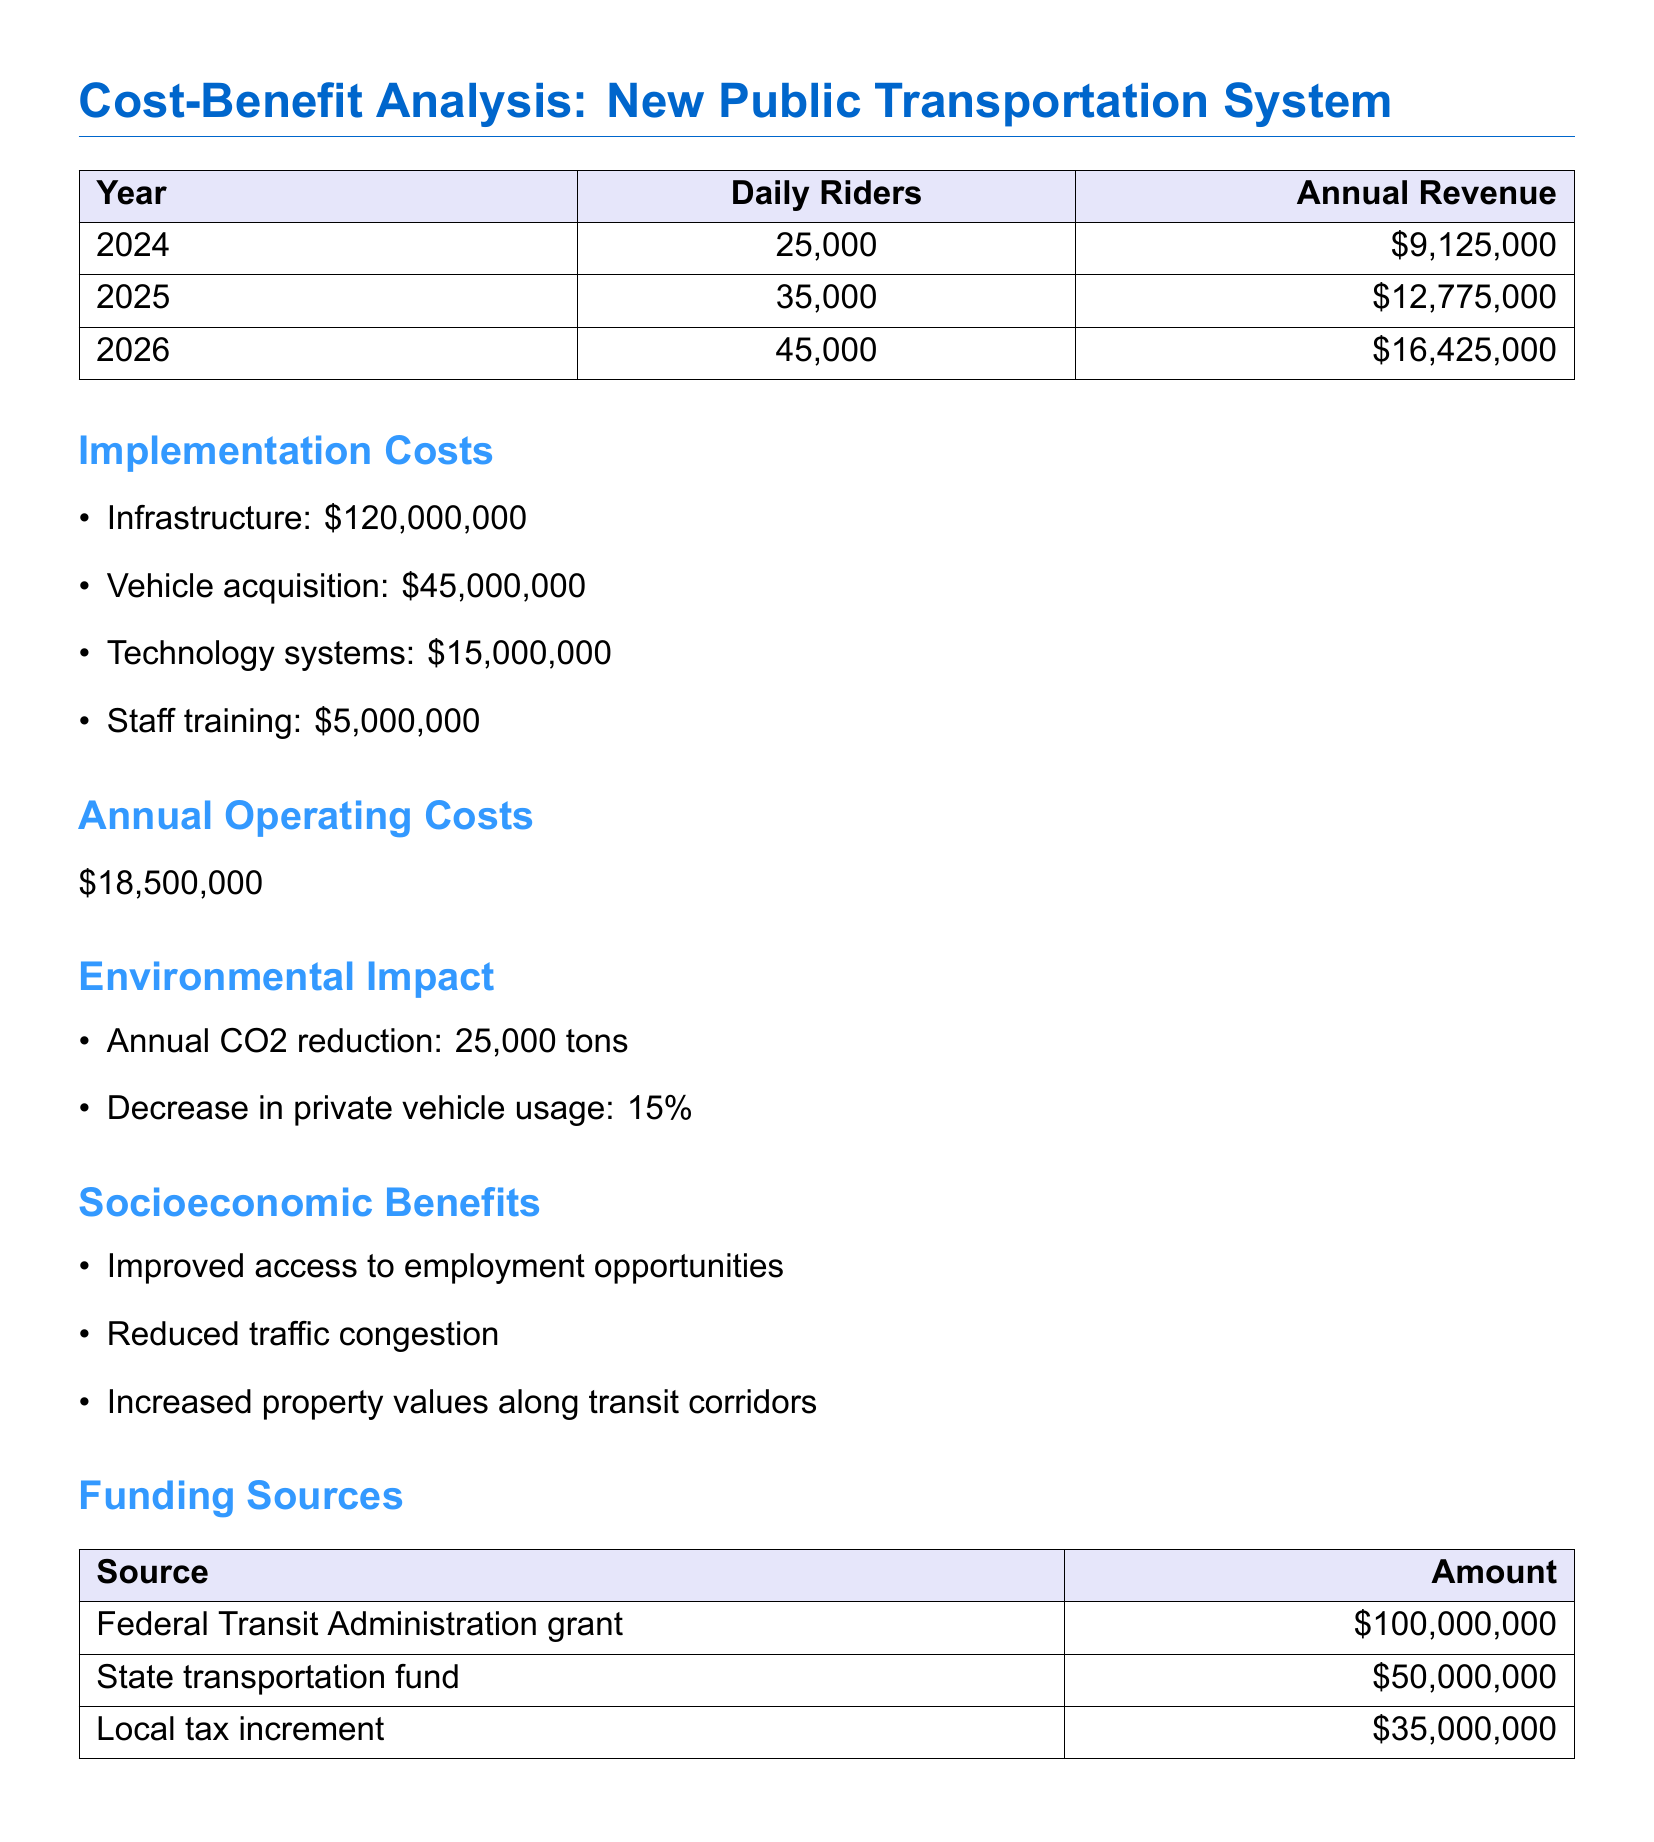What is the projected daily ridership in 2025? The document provides a table with projected daily ridership for each year, showing 35,000 for 2025.
Answer: 35,000 What is the total implementation cost? The implementation costs are individually listed; summing them gives a total of $120,000,000 + $45,000,000 + $15,000,000 + $5,000,000 = $185,000,000.
Answer: $185,000,000 What is the annual revenue in 2026? The annual revenue for 2026 is directly listed in the table as $16,425,000.
Answer: $16,425,000 By what percentage will private vehicle usage decrease? The document states a decrease in private vehicle usage of 15%.
Answer: 15% How much funding is provided by the Federal Transit Administration grant? The funding sources table indicates that the Federal Transit Administration grant is $100,000,000.
Answer: $100,000,000 What is the annual operating cost? The annual operating costs are clearly stated in the document as $18,500,000.
Answer: $18,500,000 What is the annual CO2 reduction from the new system? The environmental impact section notes an annual CO2 reduction of 25,000 tons.
Answer: 25,000 tons What socioeconomic benefit is provided by the new public transportation system? The document lists several socioeconomic benefits, one of which is improved access to employment opportunities.
Answer: Improved access to employment opportunities What is the total projected annual revenue by 2026? The projected annual revenues listed for the years are $9,125,000 (2024), $12,775,000 (2025), and $16,425,000 (2026). The total for 2026 alone is specified.
Answer: $16,425,000 